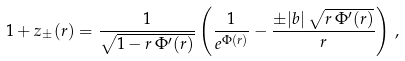Convert formula to latex. <formula><loc_0><loc_0><loc_500><loc_500>1 + z _ { \pm } ( r ) = \frac { 1 } { \sqrt { 1 - r \, \Phi ^ { \prime } ( r ) } } \left ( \frac { 1 } { e ^ { \Phi ( r ) } } - \frac { \pm | b | \, \sqrt { r \, \Phi ^ { \prime } ( r ) } } { r } \right ) \, ,</formula> 